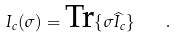<formula> <loc_0><loc_0><loc_500><loc_500>I _ { c } ( \sigma ) = \text {Tr} \{ \sigma \widehat { I } _ { c } \} \quad .</formula> 